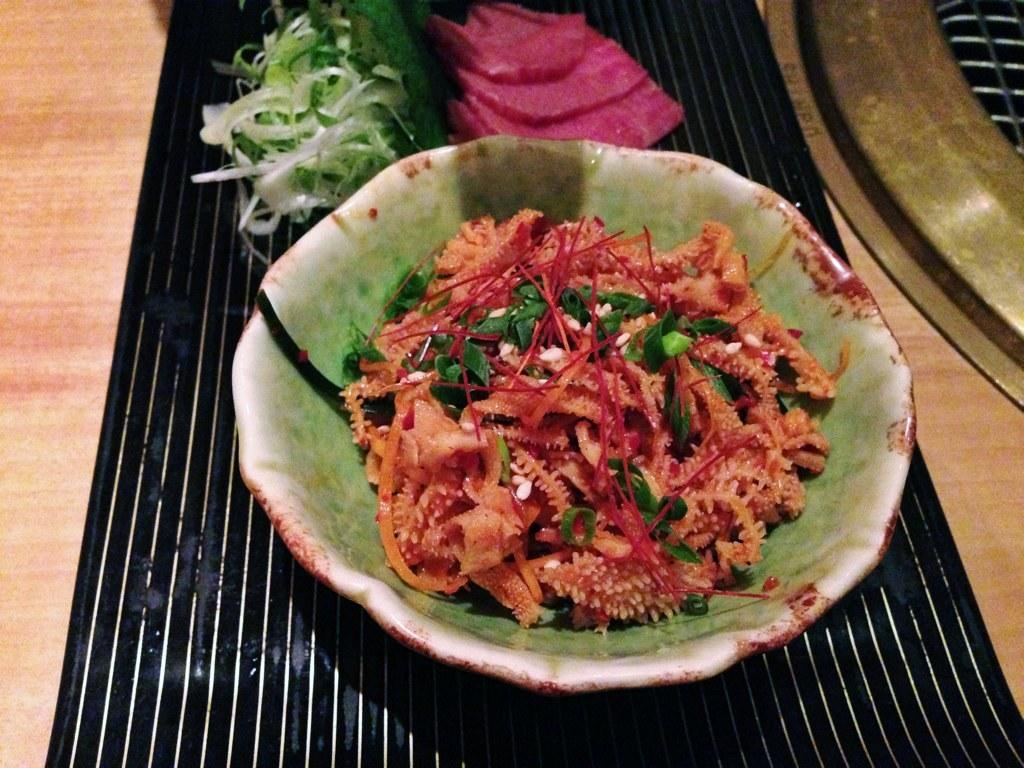What type of table is in the image? There is a wooden table in the image. What is placed on the table? There is a placemat on the table. What is on top of the placemat? There are towels and vegetables on the placemat. What is the container for the food on the placemat? There is a bowl on the placemat. What is inside the bowl? There is food in the bowl. What type of picture is hanging on the wall in the image? There is no mention of a picture or a wall in the image; it only features a wooden table with various items on it. 